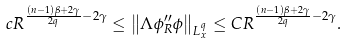Convert formula to latex. <formula><loc_0><loc_0><loc_500><loc_500>c R ^ { \frac { ( n - 1 ) \beta + 2 \gamma } { 2 q } - 2 \gamma } \leq \left \| \Lambda \phi _ { R } ^ { \prime \prime } \phi \right \| _ { L ^ { q } _ { x } } \leq C R ^ { \frac { ( n - 1 ) \beta + 2 \gamma } { 2 q } - 2 \gamma } .</formula> 